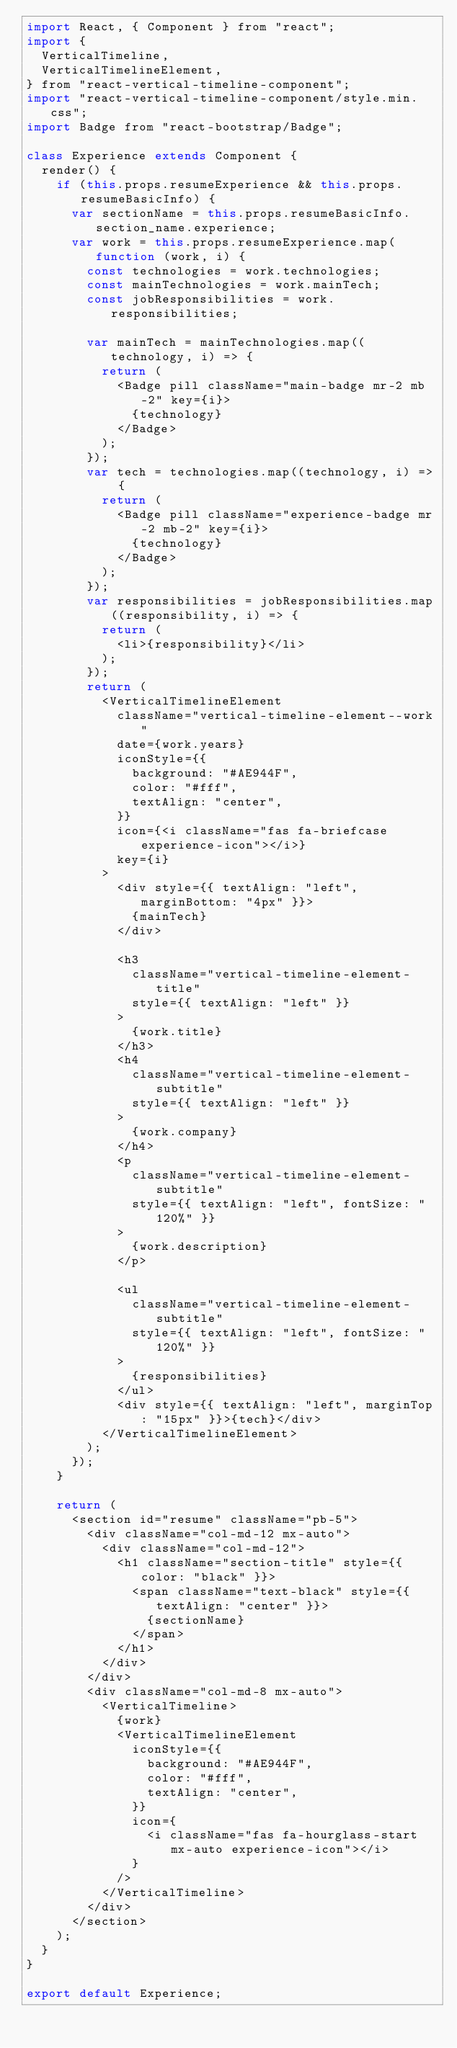<code> <loc_0><loc_0><loc_500><loc_500><_JavaScript_>import React, { Component } from "react";
import {
  VerticalTimeline,
  VerticalTimelineElement,
} from "react-vertical-timeline-component";
import "react-vertical-timeline-component/style.min.css";
import Badge from "react-bootstrap/Badge";

class Experience extends Component {
  render() {
    if (this.props.resumeExperience && this.props.resumeBasicInfo) {
      var sectionName = this.props.resumeBasicInfo.section_name.experience;
      var work = this.props.resumeExperience.map(function (work, i) {
        const technologies = work.technologies;
        const mainTechnologies = work.mainTech;
        const jobResponsibilities = work.responsibilities;

        var mainTech = mainTechnologies.map((technology, i) => {
          return (
            <Badge pill className="main-badge mr-2 mb-2" key={i}>
              {technology}
            </Badge>
          );
        });
        var tech = technologies.map((technology, i) => {
          return (
            <Badge pill className="experience-badge mr-2 mb-2" key={i}>
              {technology}
            </Badge>
          );
        });
        var responsibilities = jobResponsibilities.map((responsibility, i) => {
          return (
            <li>{responsibility}</li>
          );
        });
        return (
          <VerticalTimelineElement
            className="vertical-timeline-element--work"
            date={work.years}
            iconStyle={{
              background: "#AE944F",
              color: "#fff",
              textAlign: "center",
            }}
            icon={<i className="fas fa-briefcase experience-icon"></i>}
            key={i}
          >
            <div style={{ textAlign: "left", marginBottom: "4px" }}>
              {mainTech}
            </div>

            <h3
              className="vertical-timeline-element-title"
              style={{ textAlign: "left" }}
            >
              {work.title}
            </h3>
            <h4
              className="vertical-timeline-element-subtitle"
              style={{ textAlign: "left" }}
            >
              {work.company}
            </h4>
            <p
              className="vertical-timeline-element-subtitle"
              style={{ textAlign: "left", fontSize: "120%" }}
            >
              {work.description}
            </p>

            <ul
              className="vertical-timeline-element-subtitle"
              style={{ textAlign: "left", fontSize: "120%" }}
            >
              {responsibilities}
            </ul>
            <div style={{ textAlign: "left", marginTop: "15px" }}>{tech}</div>
          </VerticalTimelineElement>
        );
      });
    }

    return (
      <section id="resume" className="pb-5">
        <div className="col-md-12 mx-auto">
          <div className="col-md-12">
            <h1 className="section-title" style={{ color: "black" }}>
              <span className="text-black" style={{ textAlign: "center" }}>
                {sectionName}
              </span>
            </h1>
          </div>
        </div>
        <div className="col-md-8 mx-auto">
          <VerticalTimeline>
            {work}
            <VerticalTimelineElement
              iconStyle={{
                background: "#AE944F",
                color: "#fff",
                textAlign: "center",
              }}
              icon={
                <i className="fas fa-hourglass-start mx-auto experience-icon"></i>
              }
            />
          </VerticalTimeline>
        </div>
      </section>
    );
  }
}

export default Experience;
</code> 